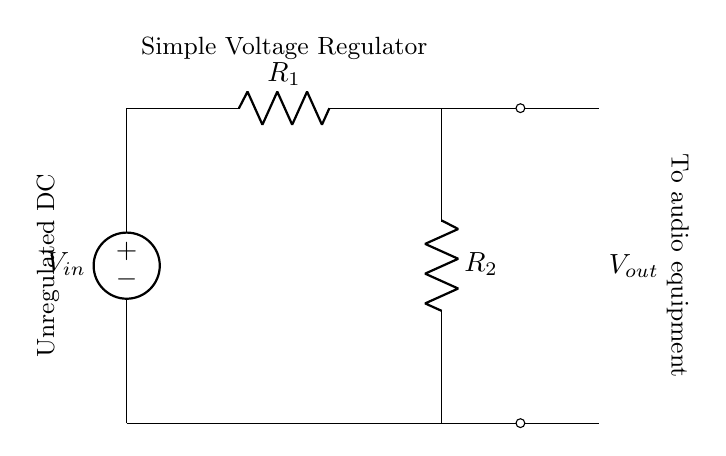What is the input voltage source labelled as? The voltage source is labelled as V_in, indicating it is the input voltage for the circuit.
Answer: V_in What type of circuit is depicted? The circuit is described as a simple voltage regulator, which is a specific type of voltage divider used to provide a stable output voltage.
Answer: Simple voltage regulator What are the resistors in the circuit? The resistors in the circuit are labelled R_1 and R_2, which are components used to divide the input voltage.
Answer: R_1, R_2 What is the output voltage labelled as? The output voltage is labelled as V_out, representing the voltage supplied to the audio equipment.
Answer: V_out How does this circuit provide voltage regulation? The circuit provides voltage regulation by dividing the input voltage across the two resistors, which allows for a stable output voltage suited for audio equipment.
Answer: By dividing input voltage What does the connection from ground to V_out signify? The connection signifies that V_out is the regulated output connected to the audio equipment, and it typically has a lower voltage compared to V_in.
Answer: Connection to audio equipment What is the function of R_1 in the circuit? R_1 functions to limit voltage drop across it, contributing to the voltage division between R_1 and R_2, which ultimately regulates the output voltage.
Answer: Limits voltage drop 